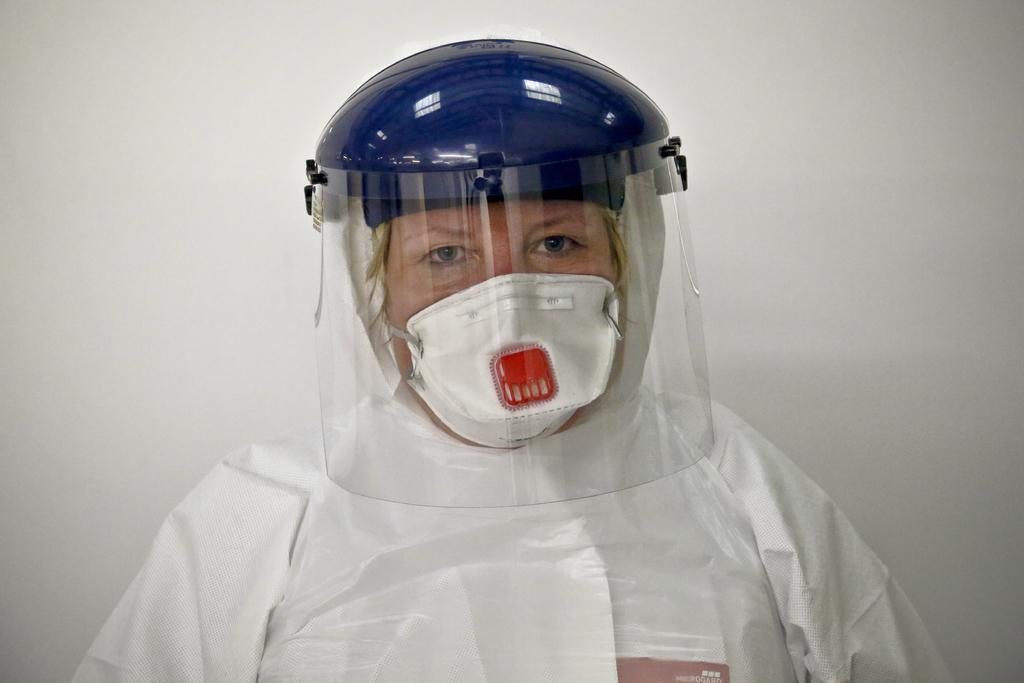Who is present in the image? There is a person in the image. What is the person wearing? The person is wearing a white dress. What other object can be seen in the image? There is a blue helmet in the image. What color is the background of the image? The background of the image is white. How many boys are present in the image? There is no mention of boys in the image, so we cannot determine their presence or number. 